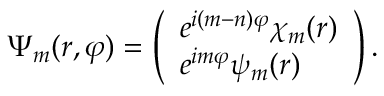Convert formula to latex. <formula><loc_0><loc_0><loc_500><loc_500>\Psi _ { m } ( r , \varphi ) = \left ( \begin{array} { l } { { e ^ { i ( m - n ) \varphi } \chi _ { m } ( r ) } } \\ { { e ^ { i m \varphi } \psi _ { m } ( r ) } } \end{array} \right ) .</formula> 